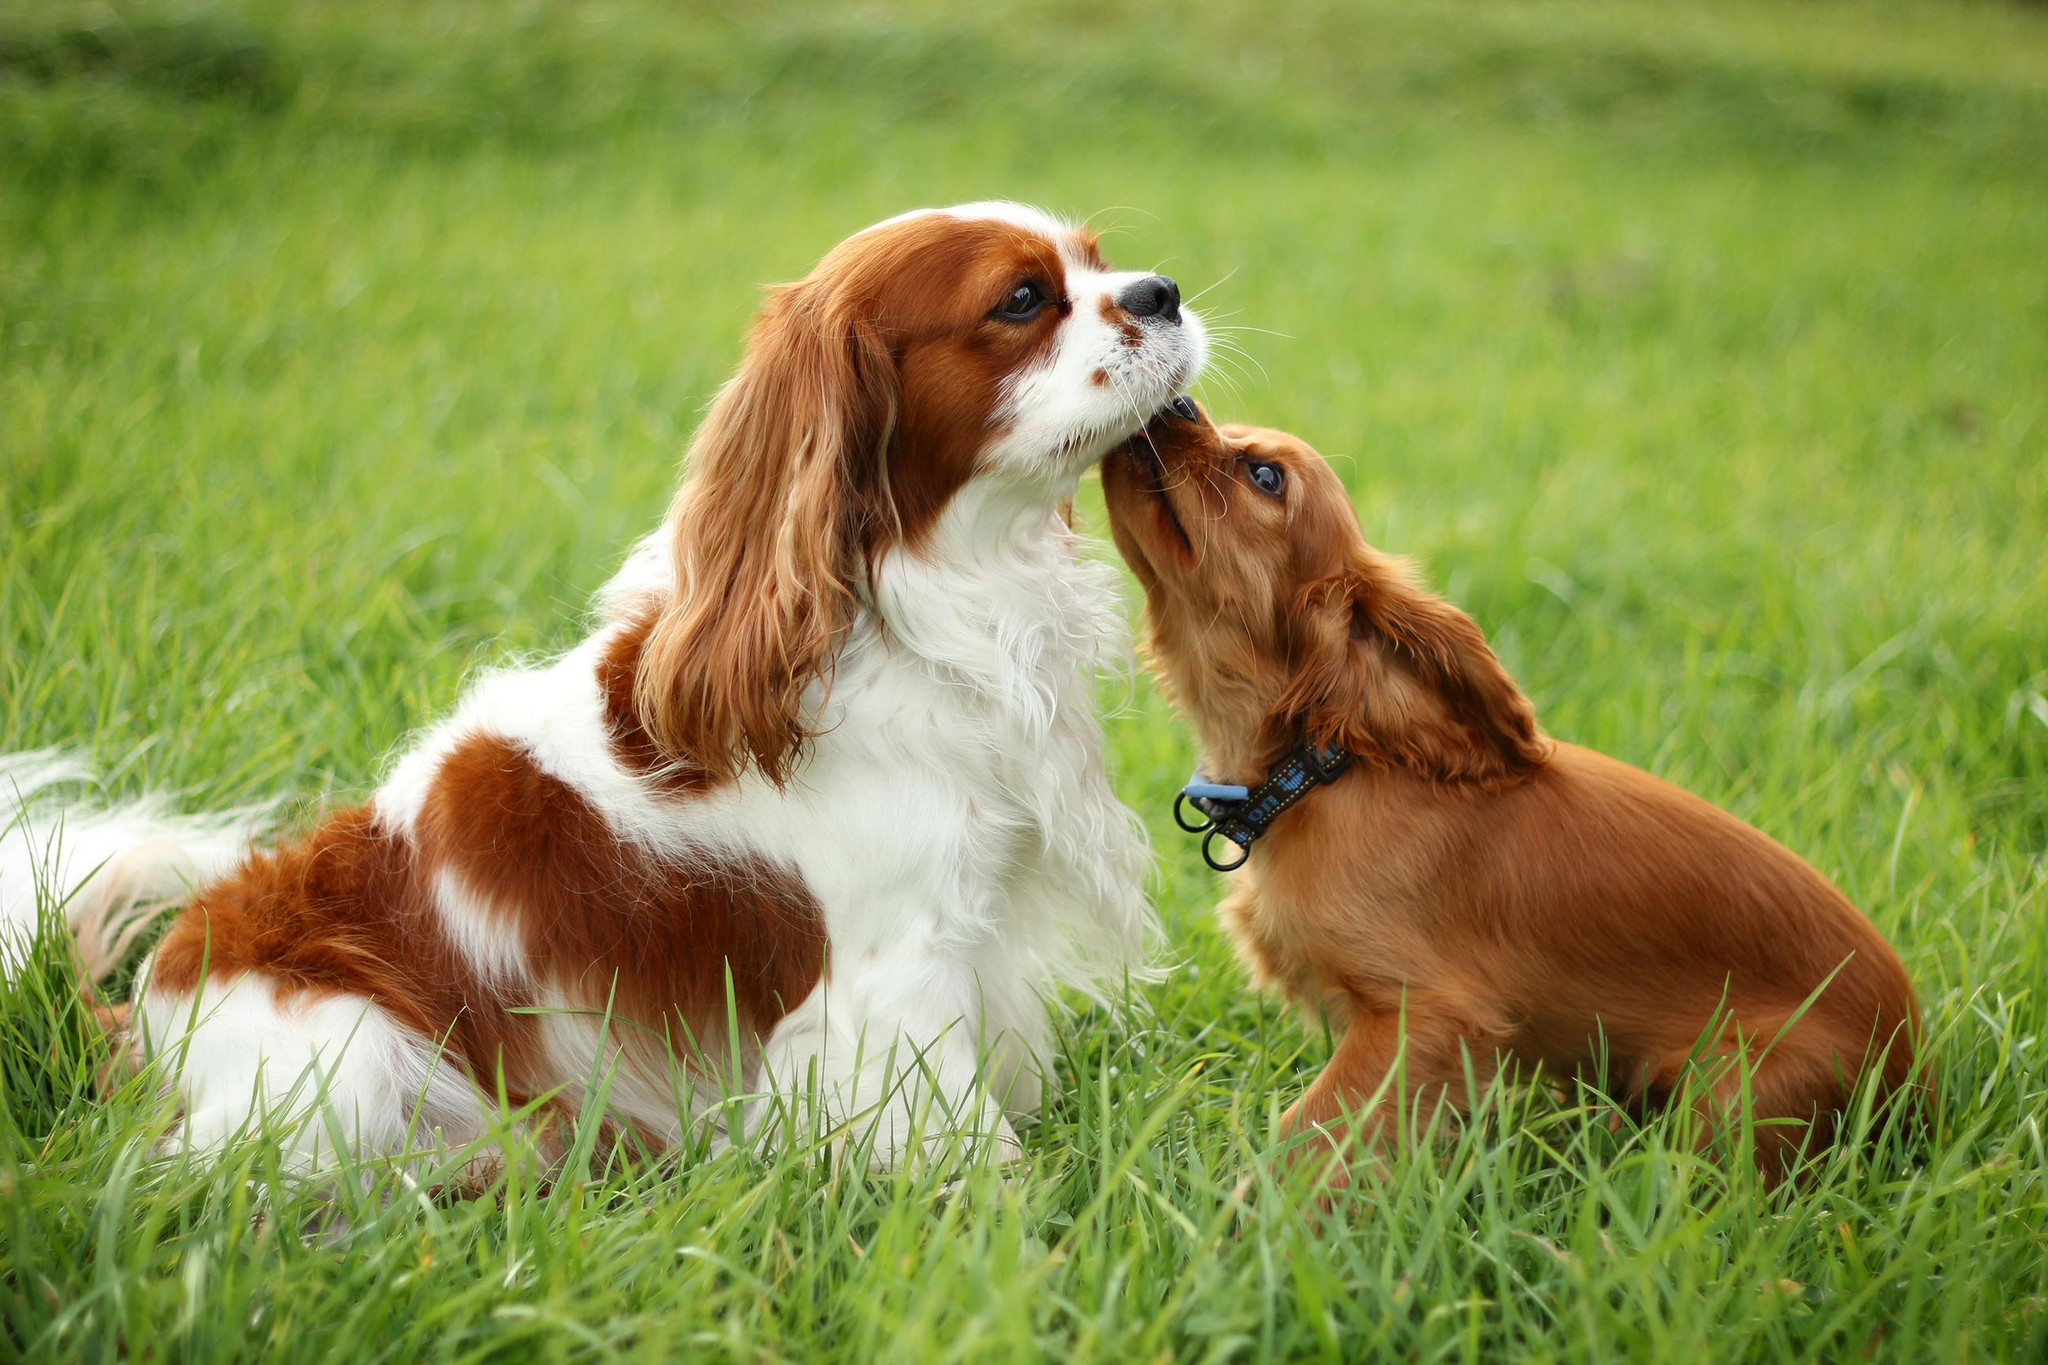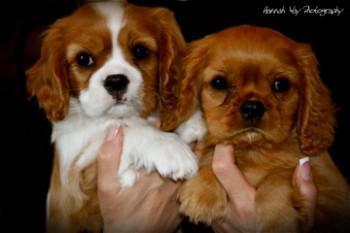The first image is the image on the left, the second image is the image on the right. Evaluate the accuracy of this statement regarding the images: "An orange spaniel is on the right of an orange-and-white spaniel, and they are face-to-face on the grass.". Is it true? Answer yes or no. Yes. The first image is the image on the left, the second image is the image on the right. Considering the images on both sides, is "In one image, a brown dog appears to try and kiss a brown and white dog under its chin" valid? Answer yes or no. Yes. 